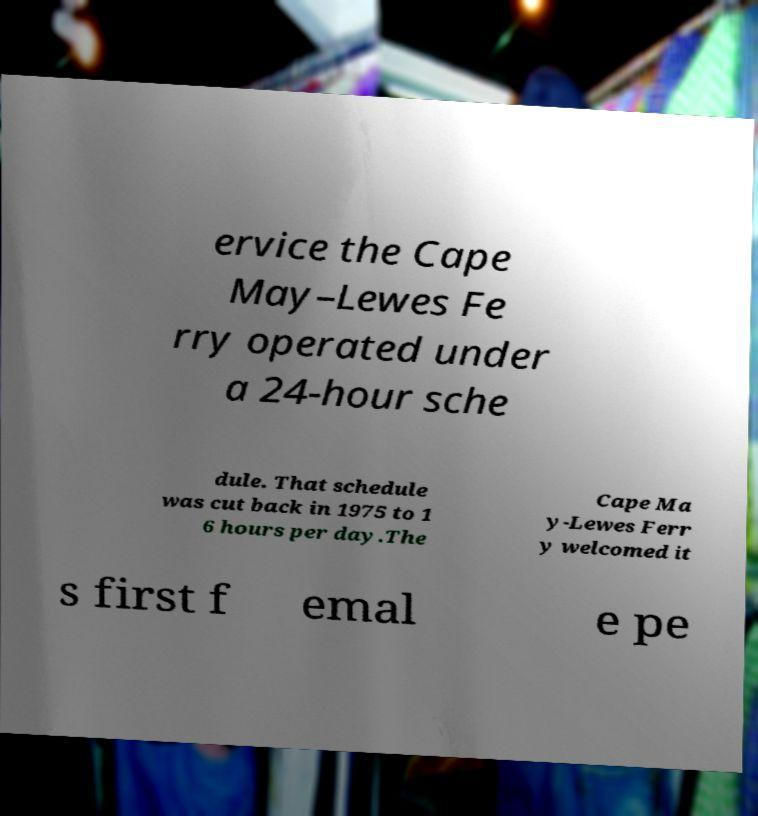Could you assist in decoding the text presented in this image and type it out clearly? ervice the Cape May–Lewes Fe rry operated under a 24-hour sche dule. That schedule was cut back in 1975 to 1 6 hours per day.The Cape Ma y-Lewes Ferr y welcomed it s first f emal e pe 